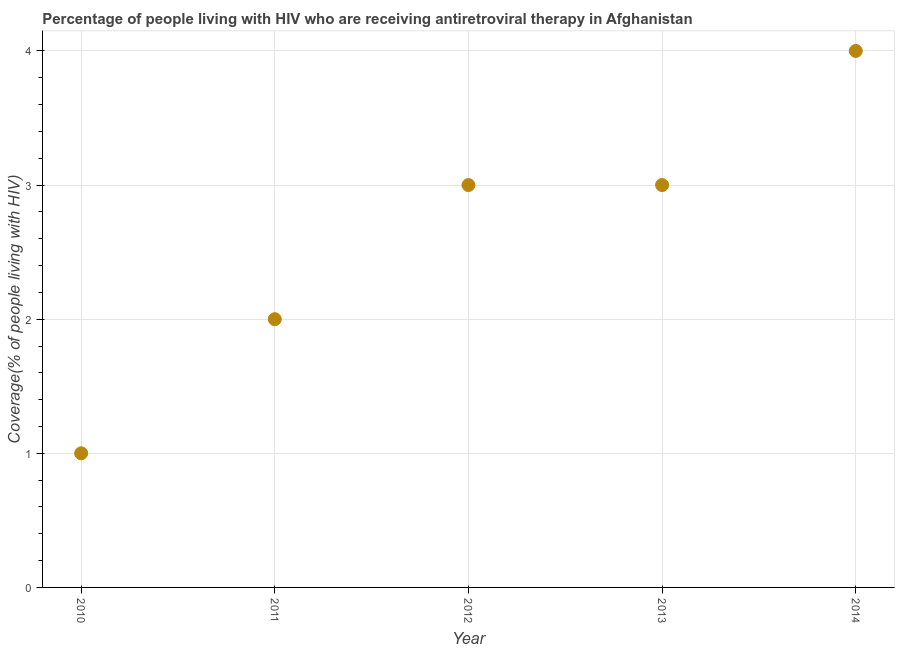What is the antiretroviral therapy coverage in 2014?
Make the answer very short. 4. Across all years, what is the maximum antiretroviral therapy coverage?
Keep it short and to the point. 4. Across all years, what is the minimum antiretroviral therapy coverage?
Offer a very short reply. 1. What is the sum of the antiretroviral therapy coverage?
Your answer should be very brief. 13. What is the difference between the antiretroviral therapy coverage in 2011 and 2013?
Keep it short and to the point. -1. What is the average antiretroviral therapy coverage per year?
Make the answer very short. 2.6. In how many years, is the antiretroviral therapy coverage greater than 0.8 %?
Keep it short and to the point. 5. Do a majority of the years between 2010 and 2011 (inclusive) have antiretroviral therapy coverage greater than 2.4 %?
Your answer should be compact. No. What is the ratio of the antiretroviral therapy coverage in 2010 to that in 2014?
Your answer should be very brief. 0.25. Is the antiretroviral therapy coverage in 2013 less than that in 2014?
Offer a very short reply. Yes. Is the difference between the antiretroviral therapy coverage in 2012 and 2014 greater than the difference between any two years?
Offer a very short reply. No. What is the difference between the highest and the second highest antiretroviral therapy coverage?
Your answer should be compact. 1. Is the sum of the antiretroviral therapy coverage in 2011 and 2014 greater than the maximum antiretroviral therapy coverage across all years?
Offer a very short reply. Yes. What is the difference between the highest and the lowest antiretroviral therapy coverage?
Keep it short and to the point. 3. Does the antiretroviral therapy coverage monotonically increase over the years?
Your response must be concise. No. How many years are there in the graph?
Your answer should be compact. 5. Does the graph contain any zero values?
Provide a short and direct response. No. What is the title of the graph?
Give a very brief answer. Percentage of people living with HIV who are receiving antiretroviral therapy in Afghanistan. What is the label or title of the X-axis?
Provide a short and direct response. Year. What is the label or title of the Y-axis?
Provide a succinct answer. Coverage(% of people living with HIV). What is the Coverage(% of people living with HIV) in 2012?
Your answer should be very brief. 3. What is the Coverage(% of people living with HIV) in 2013?
Offer a terse response. 3. What is the Coverage(% of people living with HIV) in 2014?
Your answer should be compact. 4. What is the difference between the Coverage(% of people living with HIV) in 2010 and 2012?
Your response must be concise. -2. What is the difference between the Coverage(% of people living with HIV) in 2011 and 2014?
Offer a terse response. -2. What is the difference between the Coverage(% of people living with HIV) in 2012 and 2014?
Make the answer very short. -1. What is the difference between the Coverage(% of people living with HIV) in 2013 and 2014?
Your answer should be compact. -1. What is the ratio of the Coverage(% of people living with HIV) in 2010 to that in 2011?
Provide a short and direct response. 0.5. What is the ratio of the Coverage(% of people living with HIV) in 2010 to that in 2012?
Provide a succinct answer. 0.33. What is the ratio of the Coverage(% of people living with HIV) in 2010 to that in 2013?
Keep it short and to the point. 0.33. What is the ratio of the Coverage(% of people living with HIV) in 2011 to that in 2012?
Give a very brief answer. 0.67. What is the ratio of the Coverage(% of people living with HIV) in 2011 to that in 2013?
Provide a succinct answer. 0.67. What is the ratio of the Coverage(% of people living with HIV) in 2012 to that in 2013?
Your answer should be very brief. 1. 